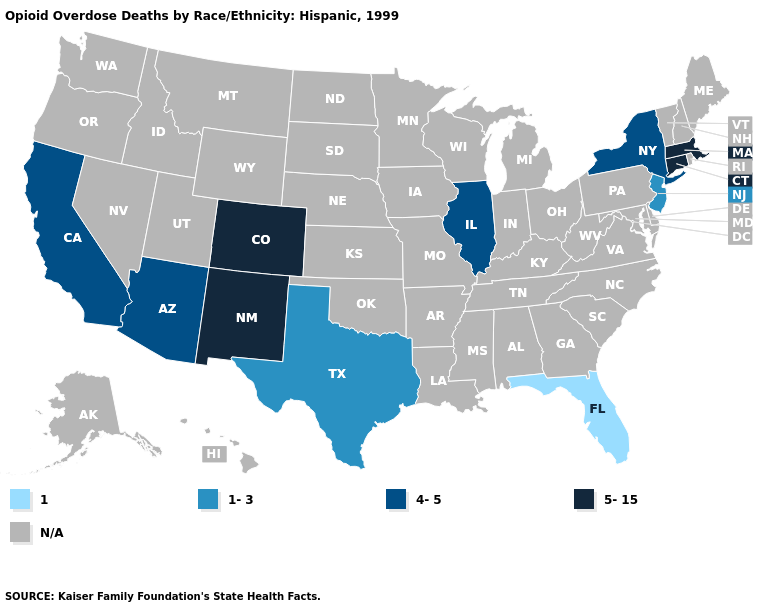What is the lowest value in the USA?
Quick response, please. 1. What is the highest value in the USA?
Quick response, please. 5-15. What is the lowest value in the USA?
Be succinct. 1. What is the highest value in the Northeast ?
Quick response, please. 5-15. How many symbols are there in the legend?
Short answer required. 5. Name the states that have a value in the range 4-5?
Give a very brief answer. Arizona, California, Illinois, New York. Which states have the lowest value in the USA?
Keep it brief. Florida. What is the value of Kansas?
Quick response, please. N/A. Which states have the highest value in the USA?
Write a very short answer. Colorado, Connecticut, Massachusetts, New Mexico. Among the states that border Massachusetts , does New York have the lowest value?
Quick response, please. Yes. What is the highest value in the Northeast ?
Concise answer only. 5-15. 